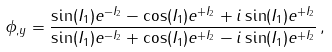<formula> <loc_0><loc_0><loc_500><loc_500>\phi _ { , y } = \frac { \sin ( I _ { 1 } ) e ^ { - I _ { 2 } } - \cos ( I _ { 1 } ) e ^ { + I _ { 2 } } + i \sin ( I _ { 1 } ) e ^ { + I _ { 2 } } } { \sin ( I _ { 1 } ) e ^ { - I _ { 2 } } + \cos ( I _ { 1 } ) e ^ { + I _ { 2 } } - i \sin ( I _ { 1 } ) e ^ { + I _ { 2 } } } \, ,</formula> 